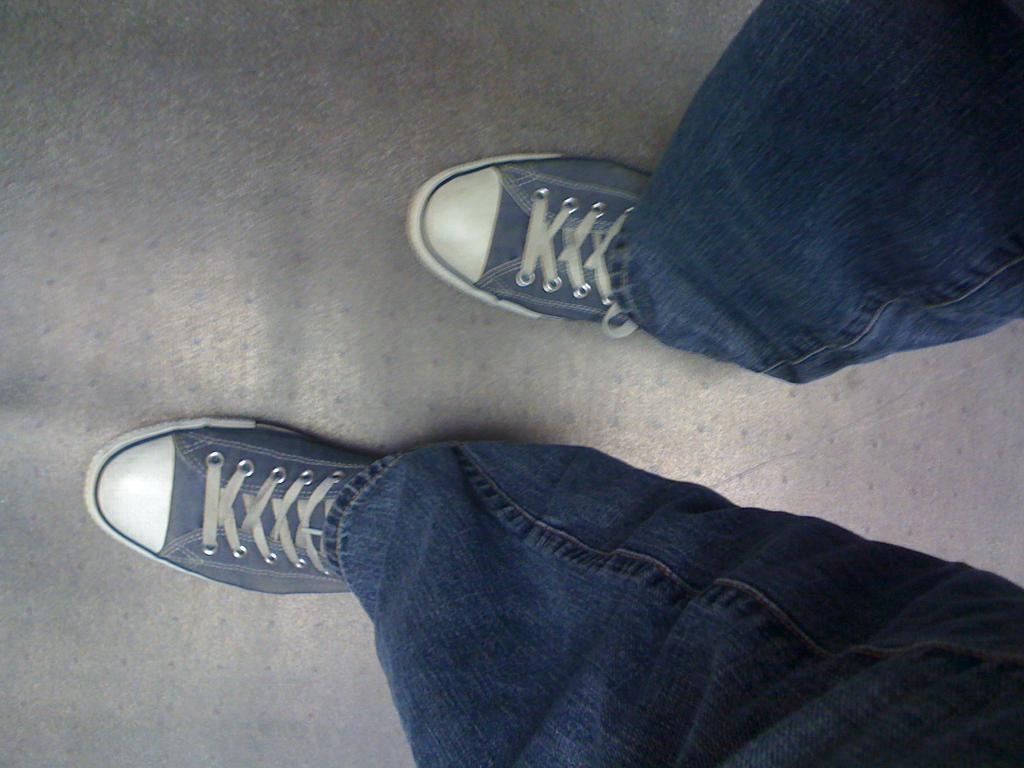What is present in the image? There is a person in the image. What part of the person's body can be seen? The person's legs are visible. What type of footwear is the person wearing? The person is wearing shoes. What type of clothing is the person wearing on their legs? The person is wearing jeans. What surface is the person standing on? The person is standing on the floor. What type of discussion is taking place in the image? There is no discussion taking place in the image; it only shows a person standing on the floor. 